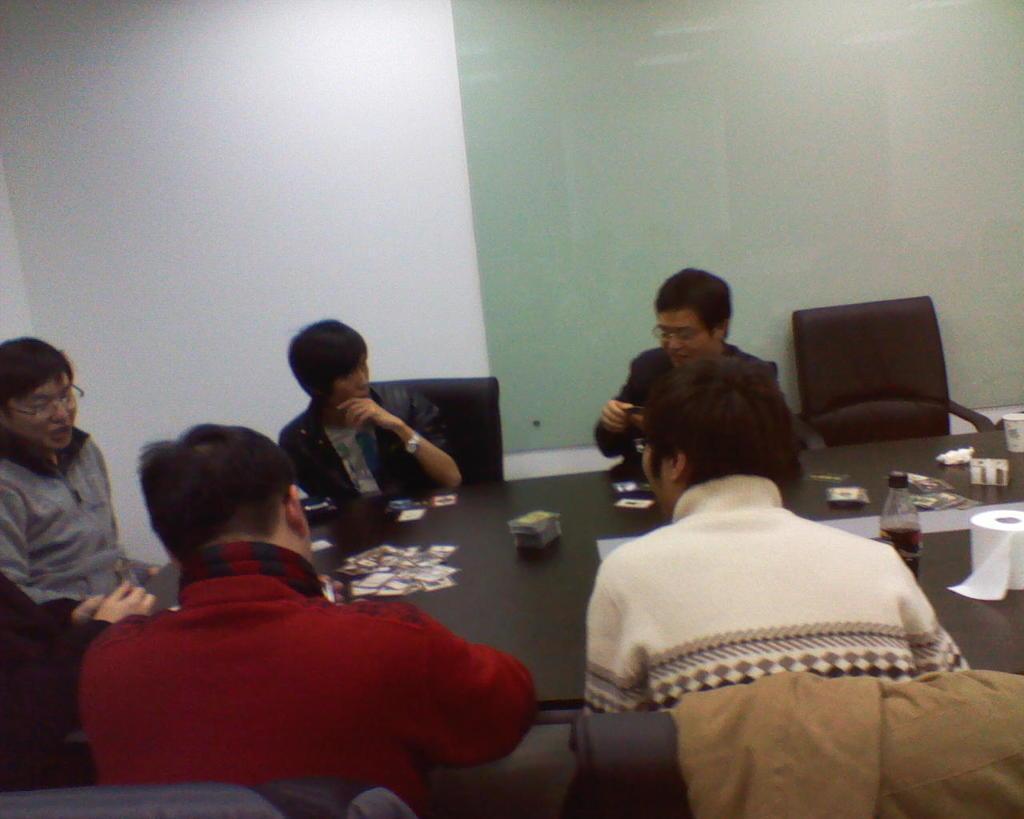Could you give a brief overview of what you see in this image? There are five people sitting on the chairs. This is a table with cards,bottle,tissue roll,paper cup on it. This is an empty chair. This is the wall. This looks like a jerkin. At the left corner of the image I can see person hand. 